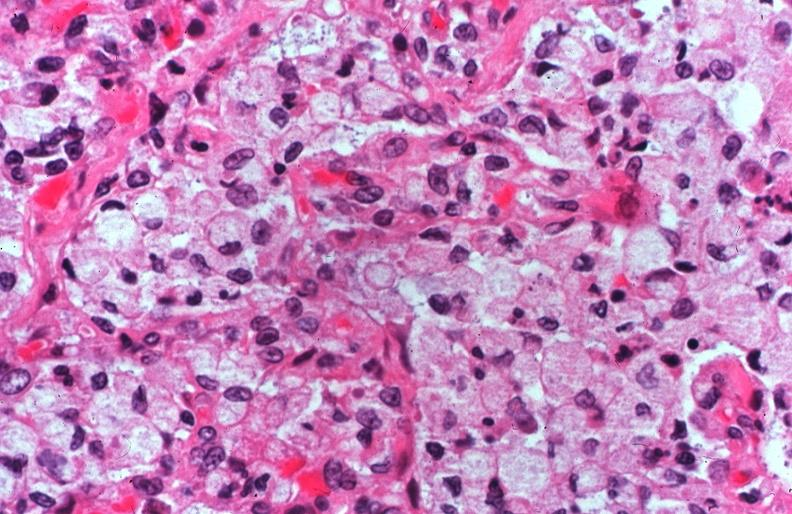does this image show lung, cystic fibrosis?
Answer the question using a single word or phrase. Yes 